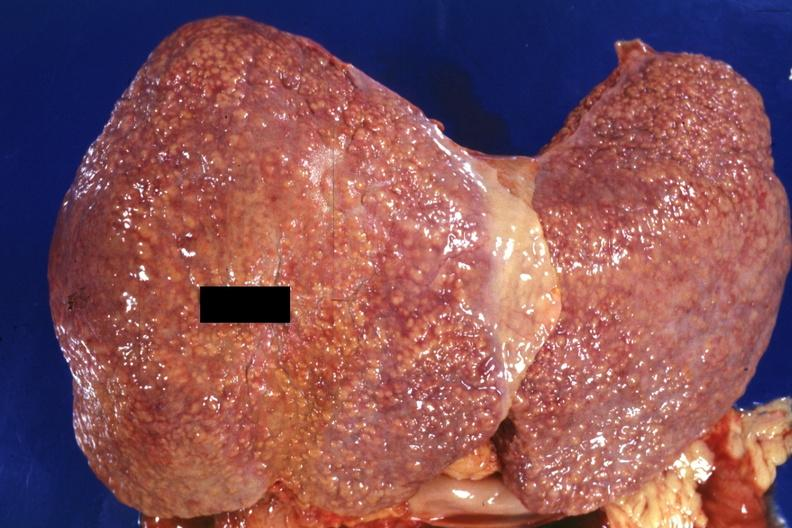s meningioma present?
Answer the question using a single word or phrase. No 